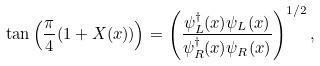<formula> <loc_0><loc_0><loc_500><loc_500>\tan \left ( \frac { \pi } { 4 } ( 1 + X ( x ) ) \right ) = \left ( \frac { \psi ^ { \dagger } _ { L } ( x ) \psi _ { L } ( x ) } { \psi ^ { \dagger } _ { R } ( x ) \psi _ { R } ( x ) } \right ) ^ { 1 / 2 } ,</formula> 